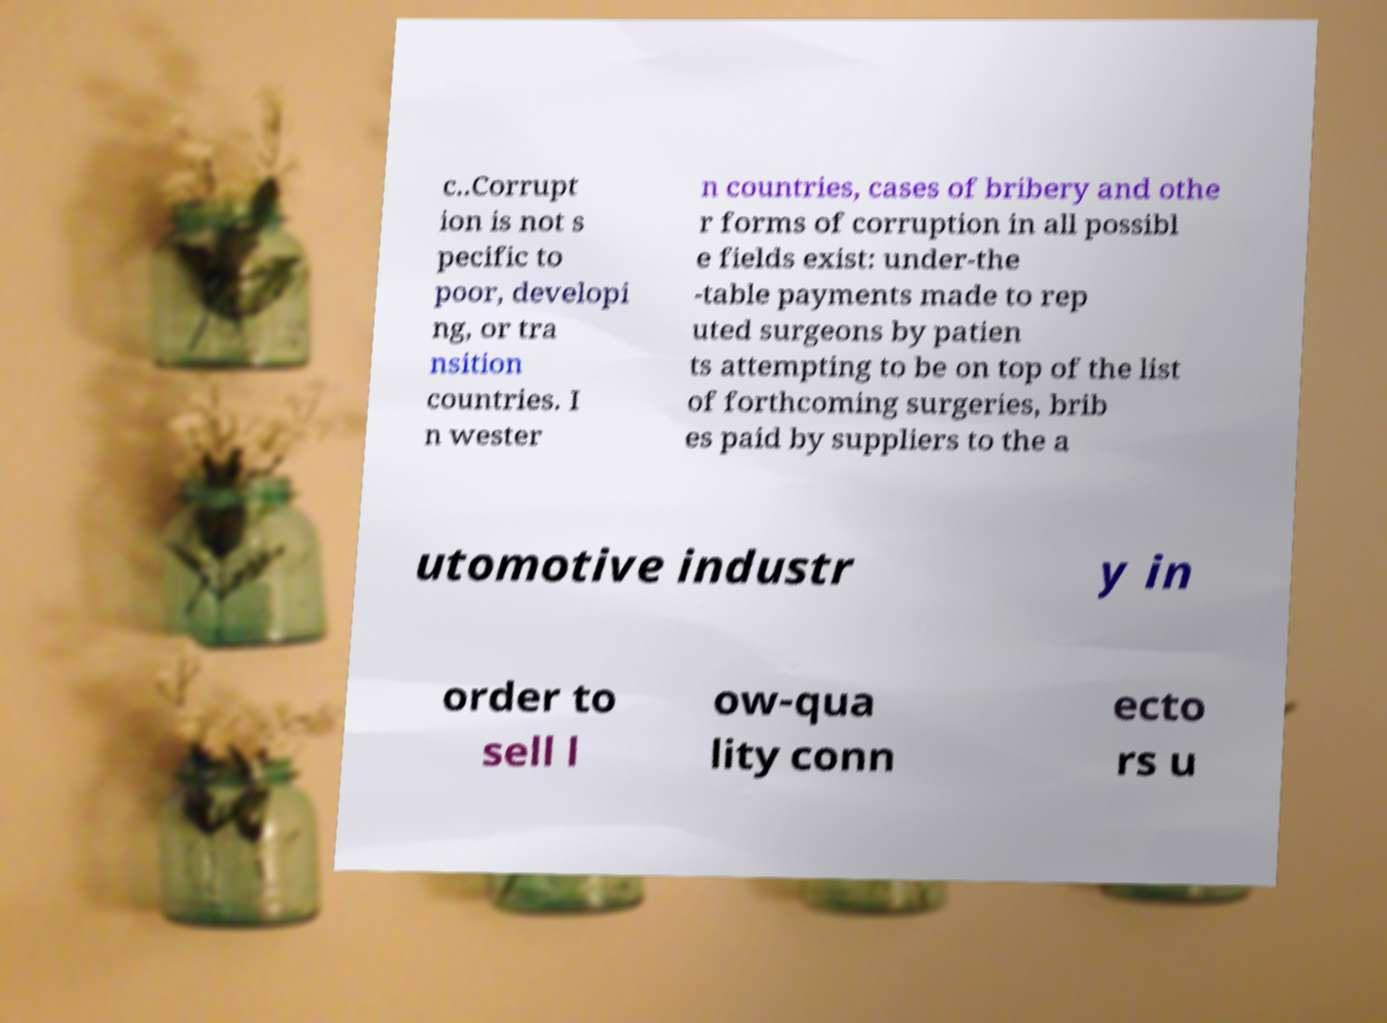I need the written content from this picture converted into text. Can you do that? c..Corrupt ion is not s pecific to poor, developi ng, or tra nsition countries. I n wester n countries, cases of bribery and othe r forms of corruption in all possibl e fields exist: under-the -table payments made to rep uted surgeons by patien ts attempting to be on top of the list of forthcoming surgeries, brib es paid by suppliers to the a utomotive industr y in order to sell l ow-qua lity conn ecto rs u 